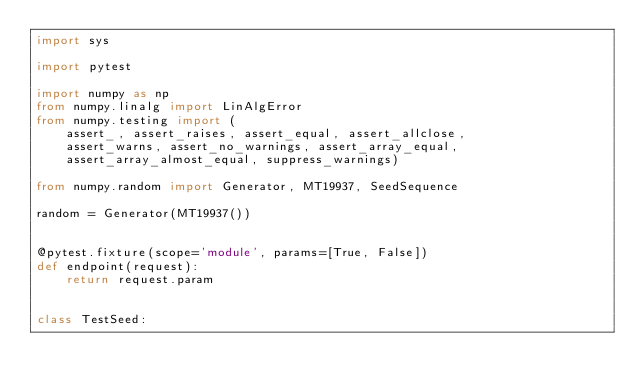Convert code to text. <code><loc_0><loc_0><loc_500><loc_500><_Python_>import sys

import pytest

import numpy as np
from numpy.linalg import LinAlgError
from numpy.testing import (
    assert_, assert_raises, assert_equal, assert_allclose,
    assert_warns, assert_no_warnings, assert_array_equal,
    assert_array_almost_equal, suppress_warnings)

from numpy.random import Generator, MT19937, SeedSequence

random = Generator(MT19937())


@pytest.fixture(scope='module', params=[True, False])
def endpoint(request):
    return request.param


class TestSeed:</code> 